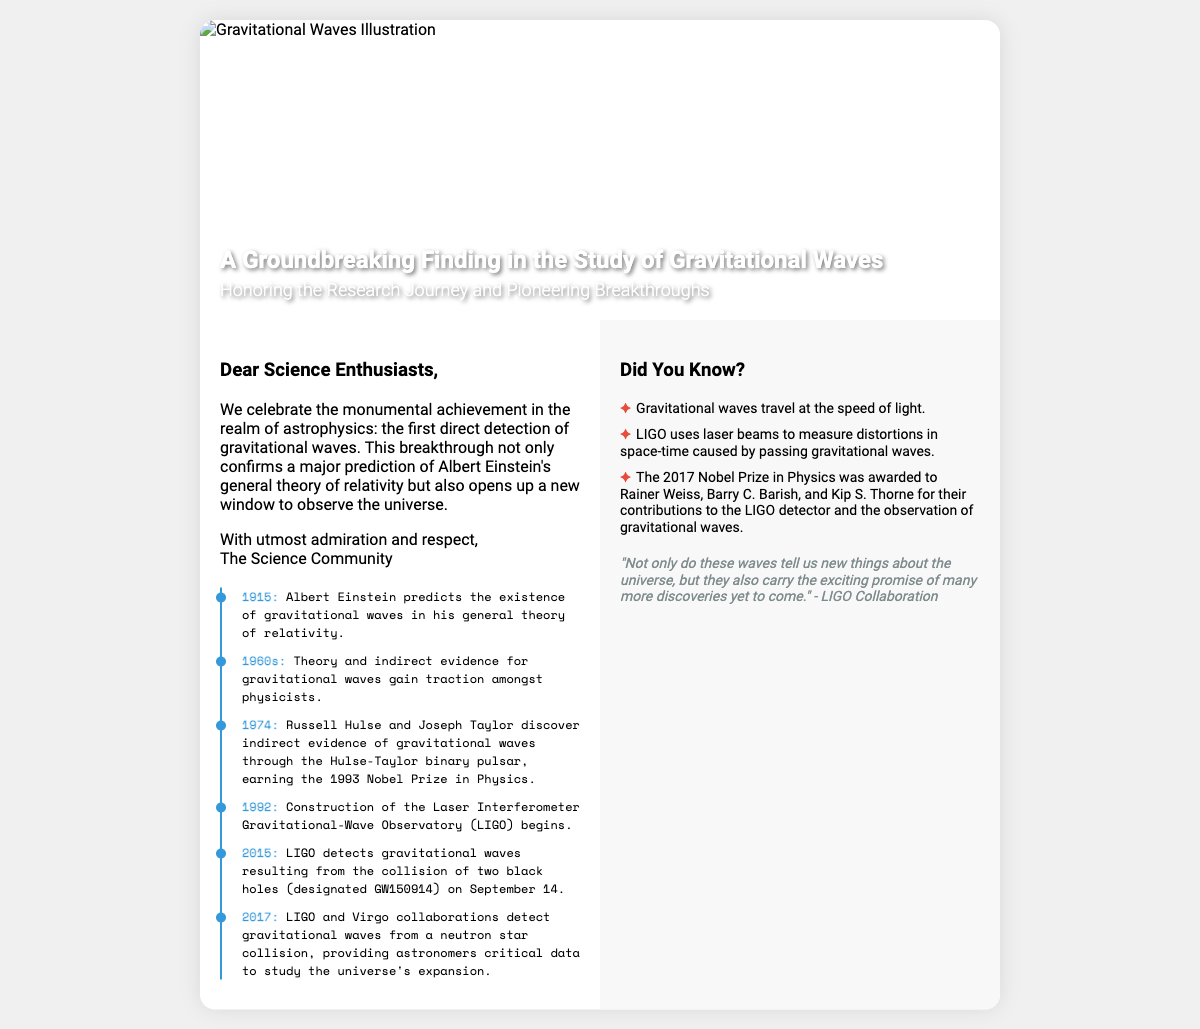What year did Einstein predict gravitational waves? The document mentions that Einstein predicted gravitational waves in 1915.
Answer: 1915 Who earned the Nobel Prize in Physics in 1993? The document states that Russell Hulse and Joseph Taylor discovered indirect evidence of gravitational waves and earned the 1993 Nobel Prize.
Answer: Russell Hulse and Joseph Taylor What was the significant event detected by LIGO in 2015? The document describes LIGO detecting gravitational waves from the collision of two black holes, designated GW150914.
Answer: GW150914 What speed do gravitational waves travel? The card mentions that gravitational waves travel at the speed of light.
Answer: Speed of light What is the focus of the timeline included in the card? The timeline details key events and breakthroughs in the study of gravitational waves, such as predictions and discoveries.
Answer: Key events and breakthroughs in gravitational waves Which observatory's construction began in 1992? The document lists that the construction of the Laser Interferometer Gravitational-Wave Observatory (LIGO) began in 1992.
Answer: LIGO What did the 2017 Nobel Prize in Physics recognize? The document notes that the prize was awarded to Rainer Weiss, Barry C. Barish, and Kip S. Thorne for their contributions to LIGO and gravitational waves.
Answer: Contributions to LIGO and gravitational waves What genre of card is this document presenting? The document is designed as a greeting card celebrating a scientific discovery in astrophysics.
Answer: Greeting card 